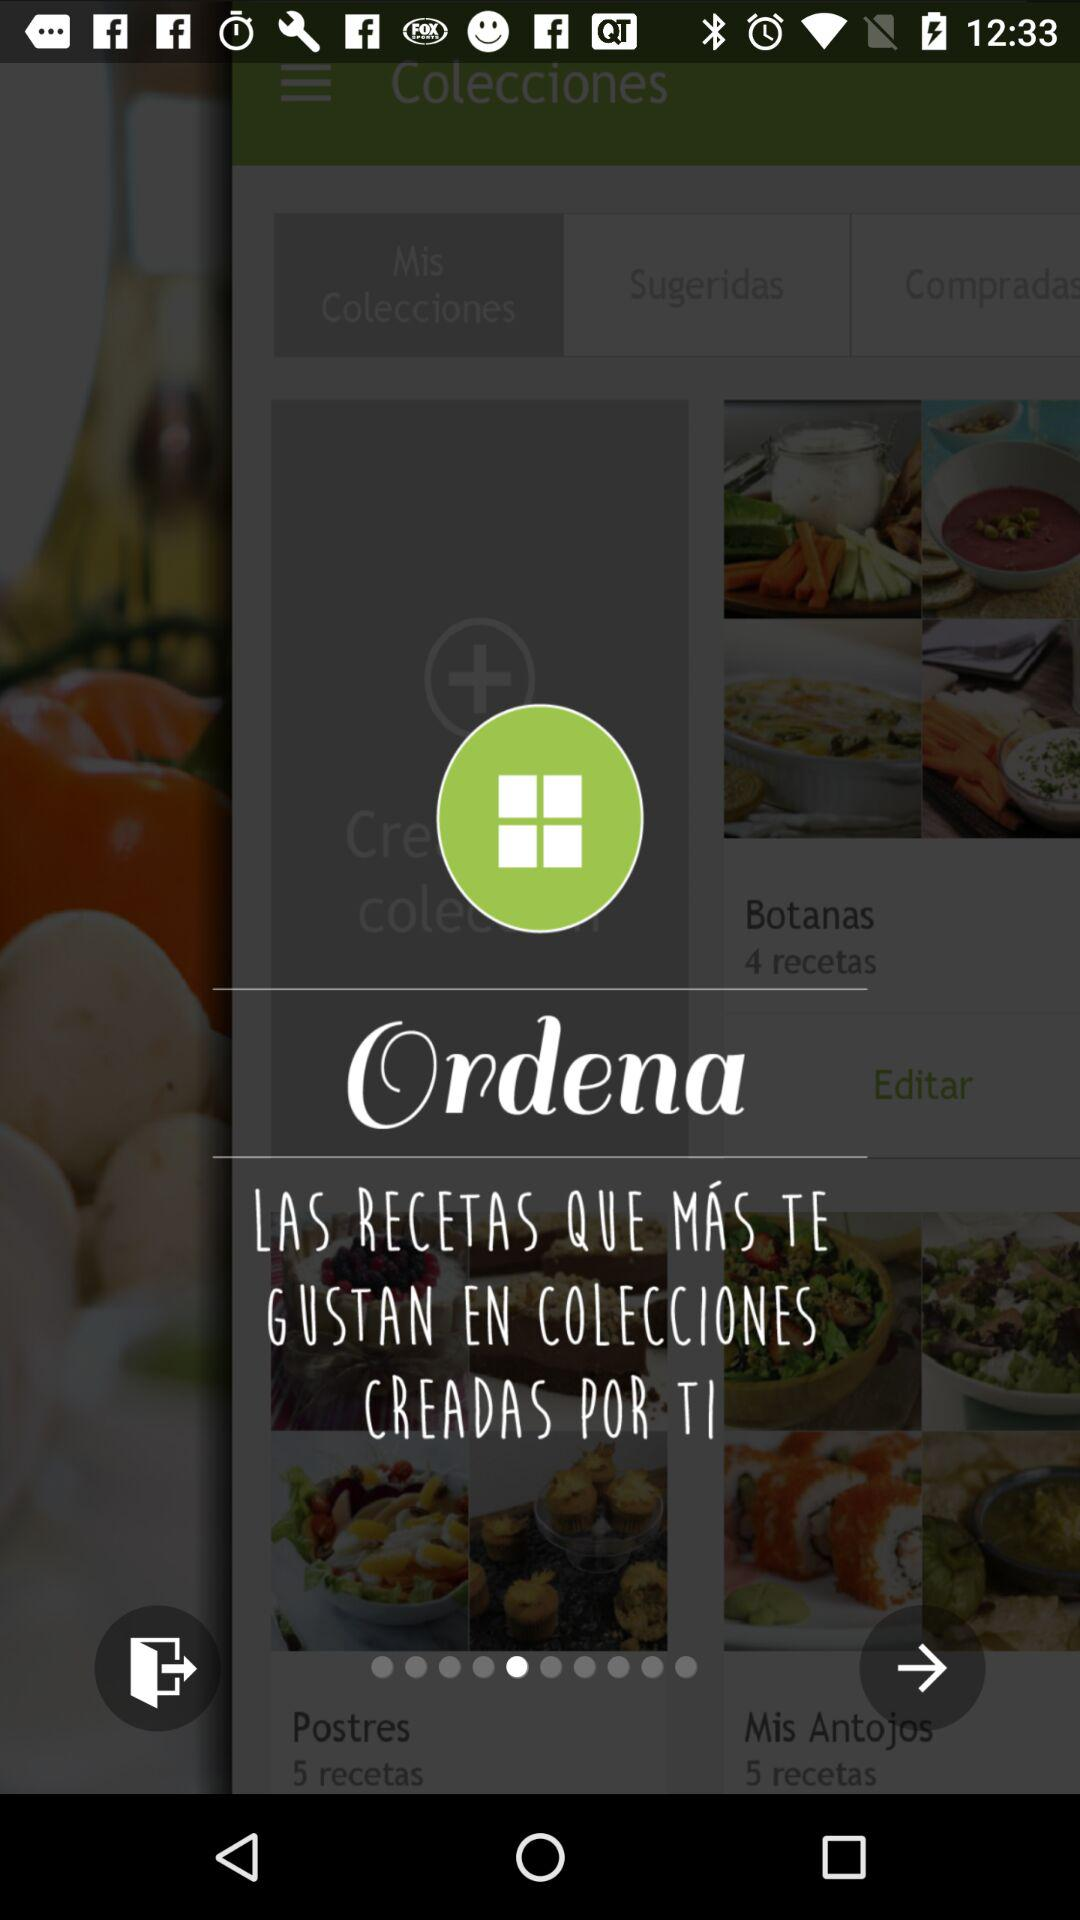How many arrows are pointing to the right?
Answer the question using a single word or phrase. 2 